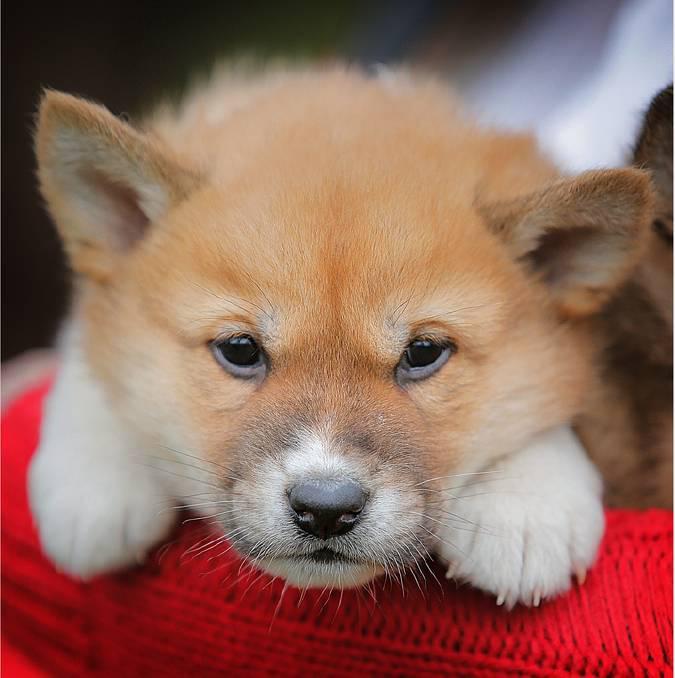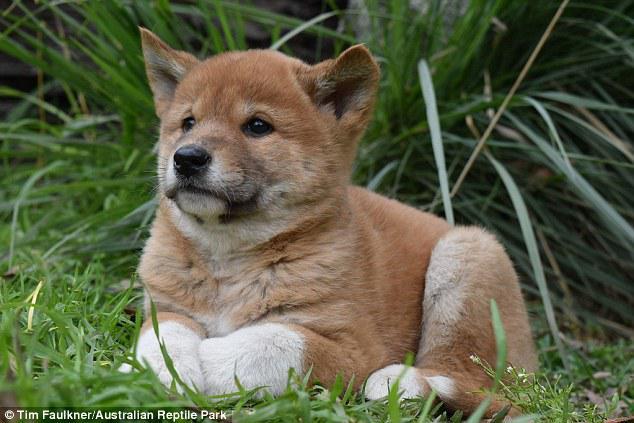The first image is the image on the left, the second image is the image on the right. Assess this claim about the two images: "In the image on the right there are 2 puppies.". Correct or not? Answer yes or no. No. The first image is the image on the left, the second image is the image on the right. For the images displayed, is the sentence "At least one person is behind exactly two young dogs in the right image." factually correct? Answer yes or no. No. 